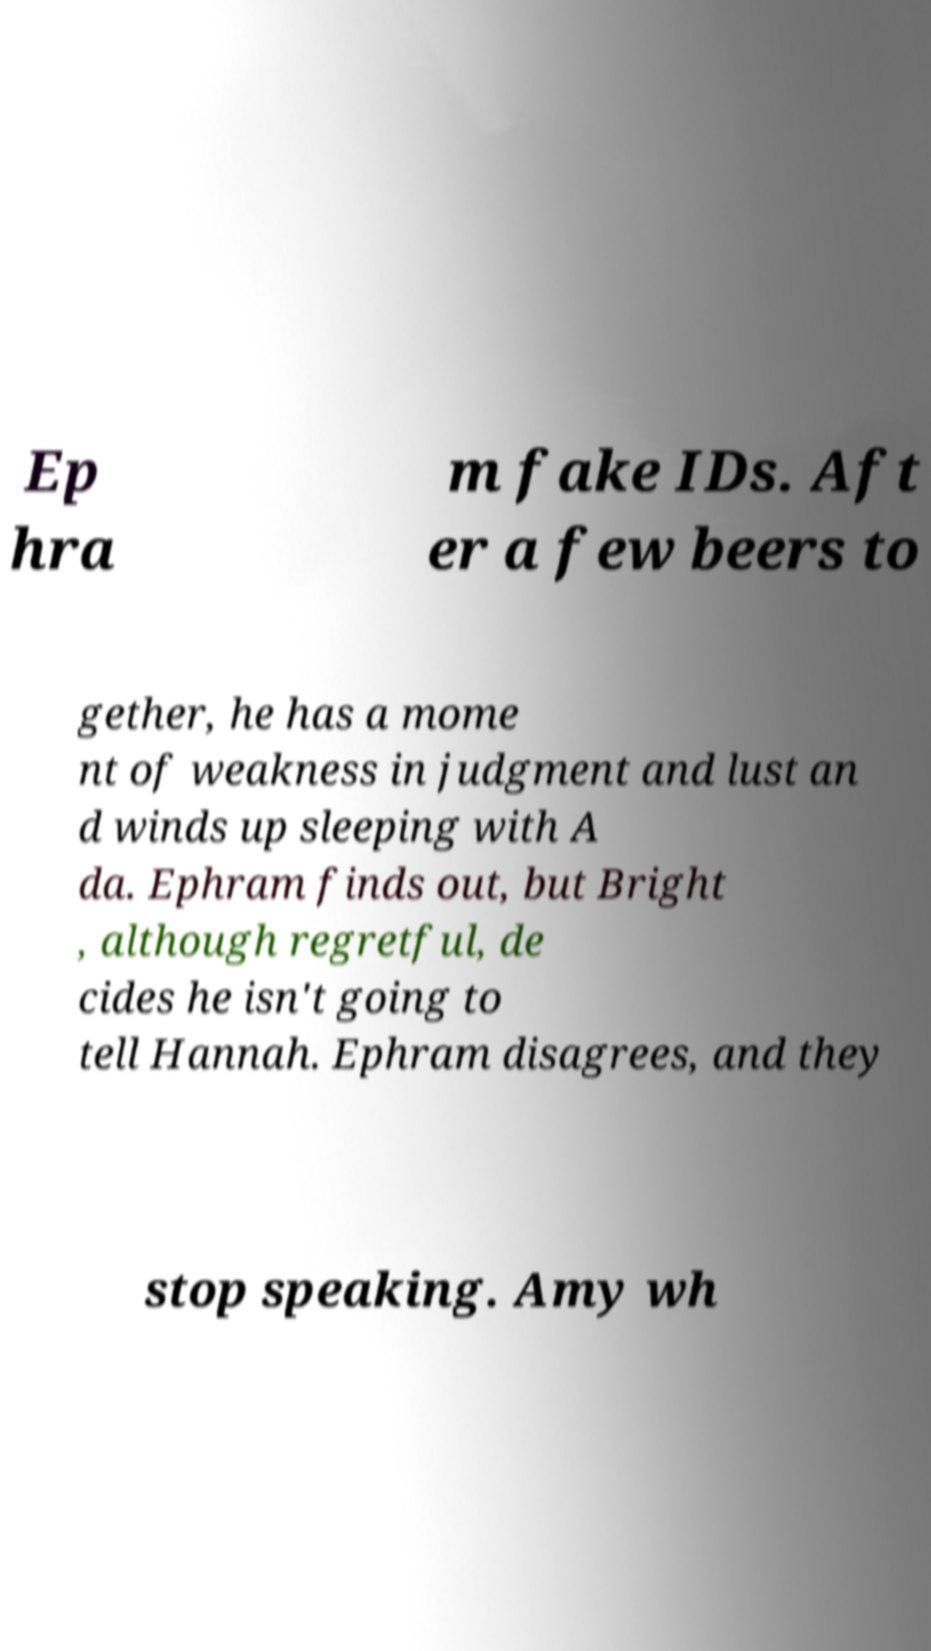Please read and relay the text visible in this image. What does it say? Ep hra m fake IDs. Aft er a few beers to gether, he has a mome nt of weakness in judgment and lust an d winds up sleeping with A da. Ephram finds out, but Bright , although regretful, de cides he isn't going to tell Hannah. Ephram disagrees, and they stop speaking. Amy wh 